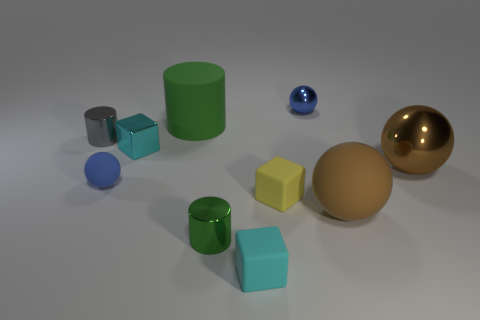Subtract all cylinders. How many objects are left? 7 Add 1 gray shiny objects. How many gray shiny objects are left? 2 Add 7 blue cylinders. How many blue cylinders exist? 7 Subtract 0 purple cylinders. How many objects are left? 10 Subtract all large brown metallic balls. Subtract all rubber cylinders. How many objects are left? 8 